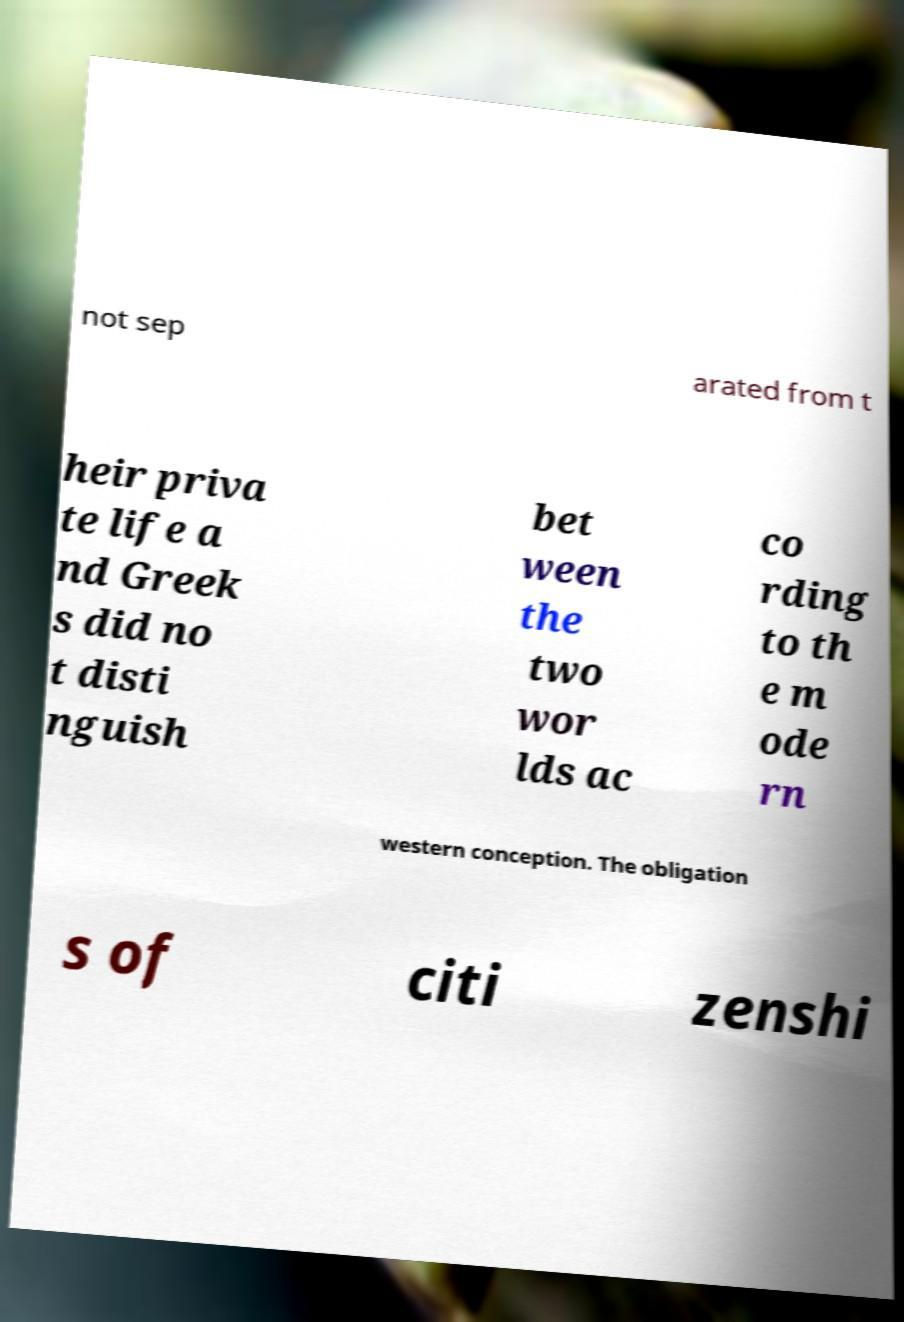I need the written content from this picture converted into text. Can you do that? not sep arated from t heir priva te life a nd Greek s did no t disti nguish bet ween the two wor lds ac co rding to th e m ode rn western conception. The obligation s of citi zenshi 